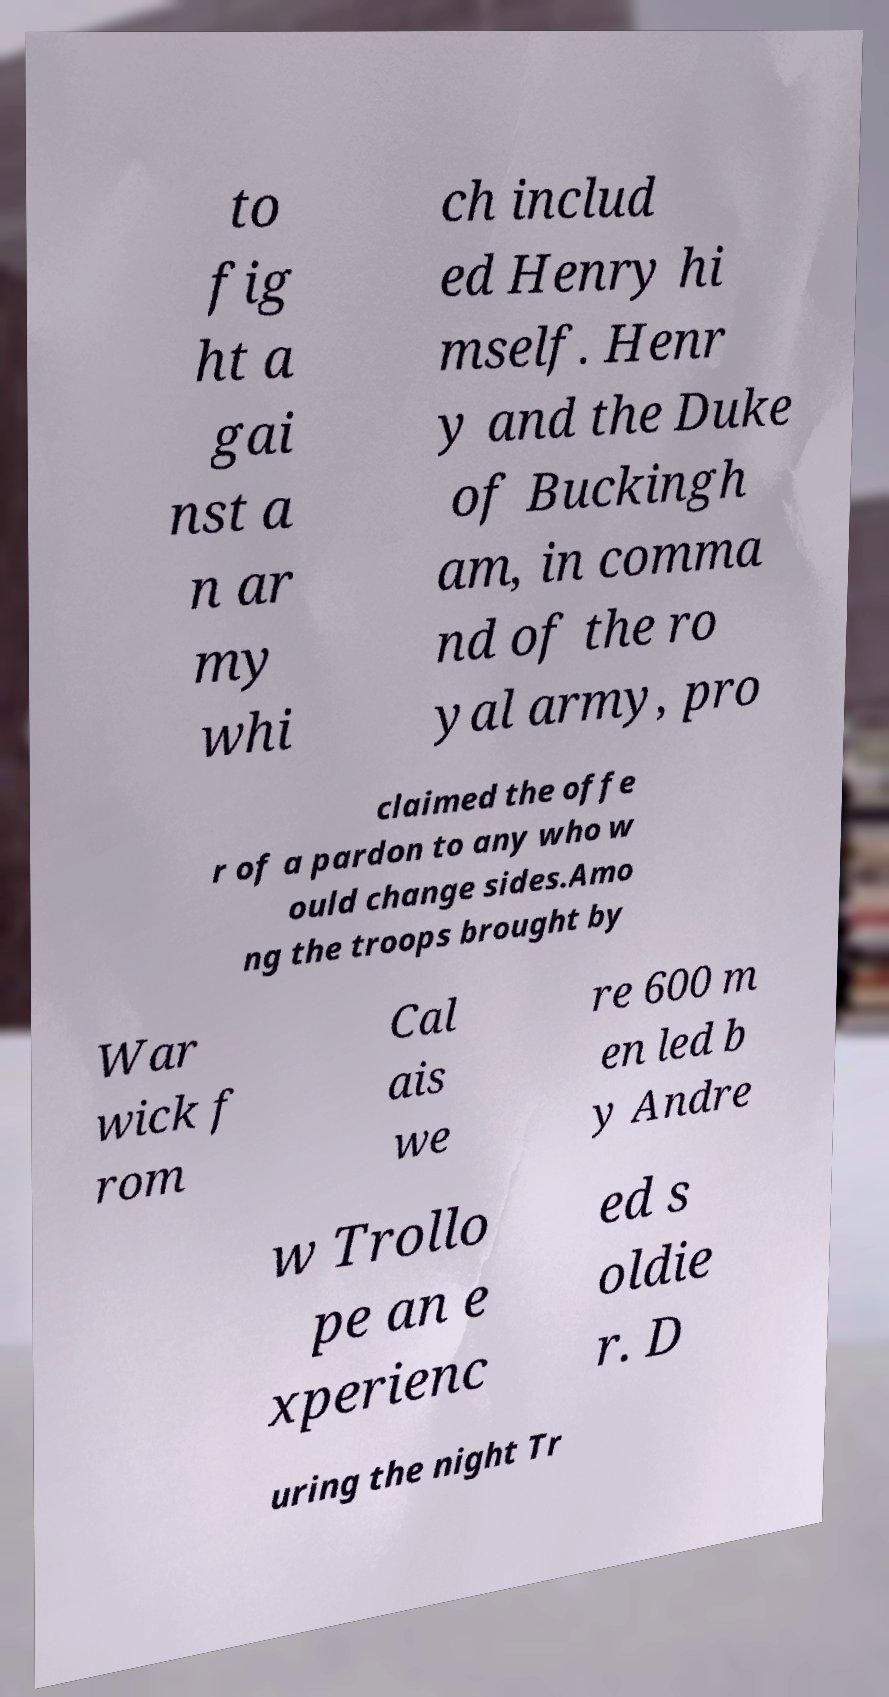Can you read and provide the text displayed in the image?This photo seems to have some interesting text. Can you extract and type it out for me? to fig ht a gai nst a n ar my whi ch includ ed Henry hi mself. Henr y and the Duke of Buckingh am, in comma nd of the ro yal army, pro claimed the offe r of a pardon to any who w ould change sides.Amo ng the troops brought by War wick f rom Cal ais we re 600 m en led b y Andre w Trollo pe an e xperienc ed s oldie r. D uring the night Tr 